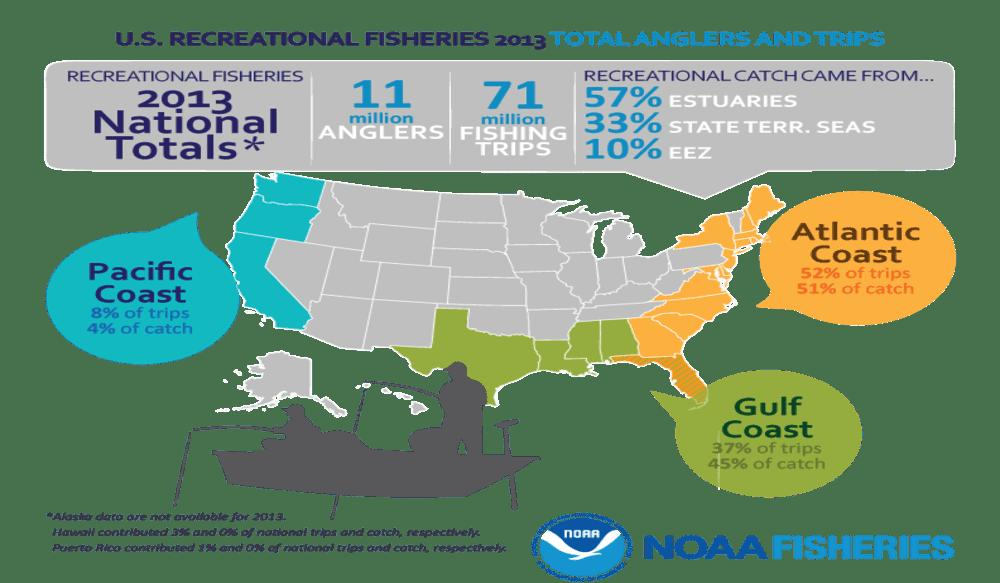Specify some key components in this picture. According to the U.S. Recreational Fisheries data from 2013, a total of 11 million anglers participated in the recreational fishing activities. According to the 2013 data from the U.S. Recreational Fisheries, the Atlantic Coast saw the highest percentage of catches among all coasts in the United States. According to the U.S. Recreational Fisheries data from 2013, 52% of all trips were made along the Atlantic coast. According to the U.S. Recreational Fisheries 2013 data, the Pacific Coast of the United States had the least percentage of catches compared to the other coasts in the country. According to the 2013 U.S. Recreational Fisheries Survey, a total of 71 million fishing trips were taken. 